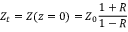Convert formula to latex. <formula><loc_0><loc_0><loc_500><loc_500>Z _ { t } = Z ( z = 0 ) = Z _ { 0 } \frac { 1 + R } { 1 - R }</formula> 